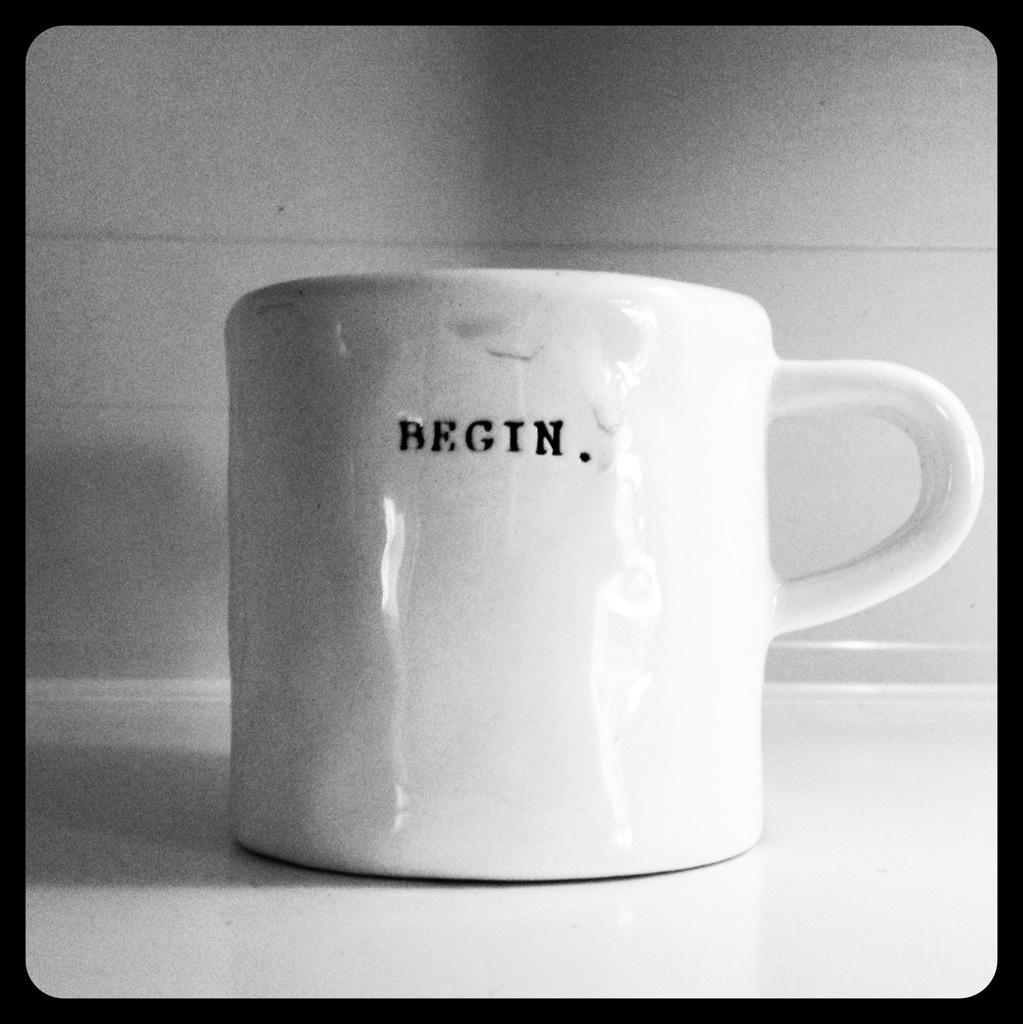<image>
Describe the image concisely. A nondescript white coffee mug has the word BEGIN on it in capital letters followed by a period. 